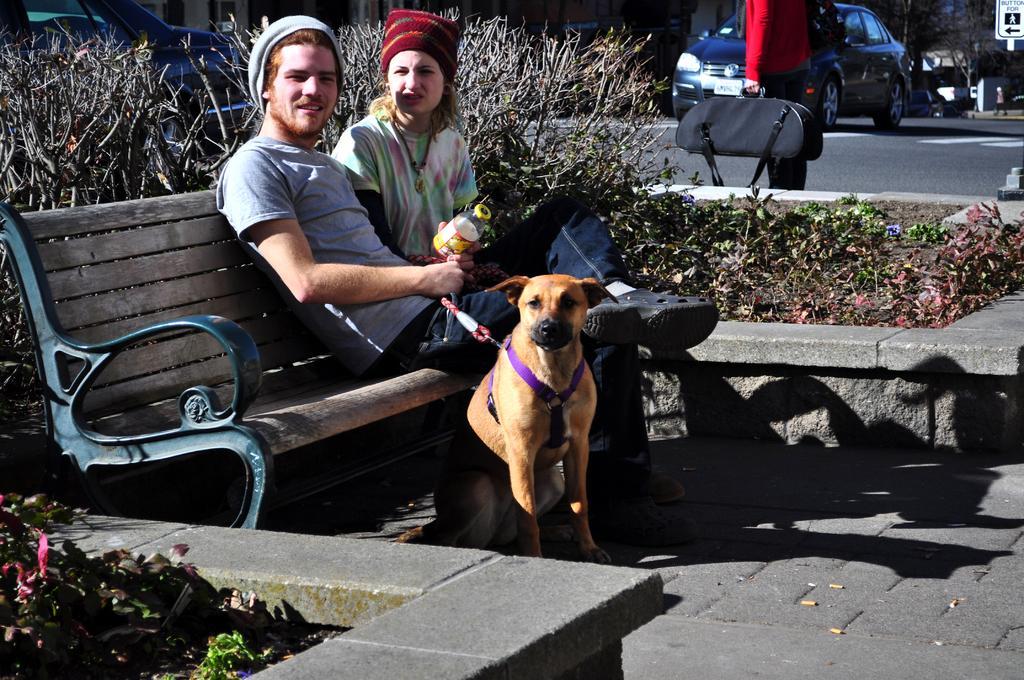Describe this image in one or two sentences. This picture is clicked outside in the city. There is a man and a woman sitting on bench. the man is holding a bottle and leash in his hand. In front of the bench there is a dog sitting on the ground. Behind them there are plants. In the background there are buildings, cars, trees and road. There is another person walking on the road carrying a luggage bag in his hand. 